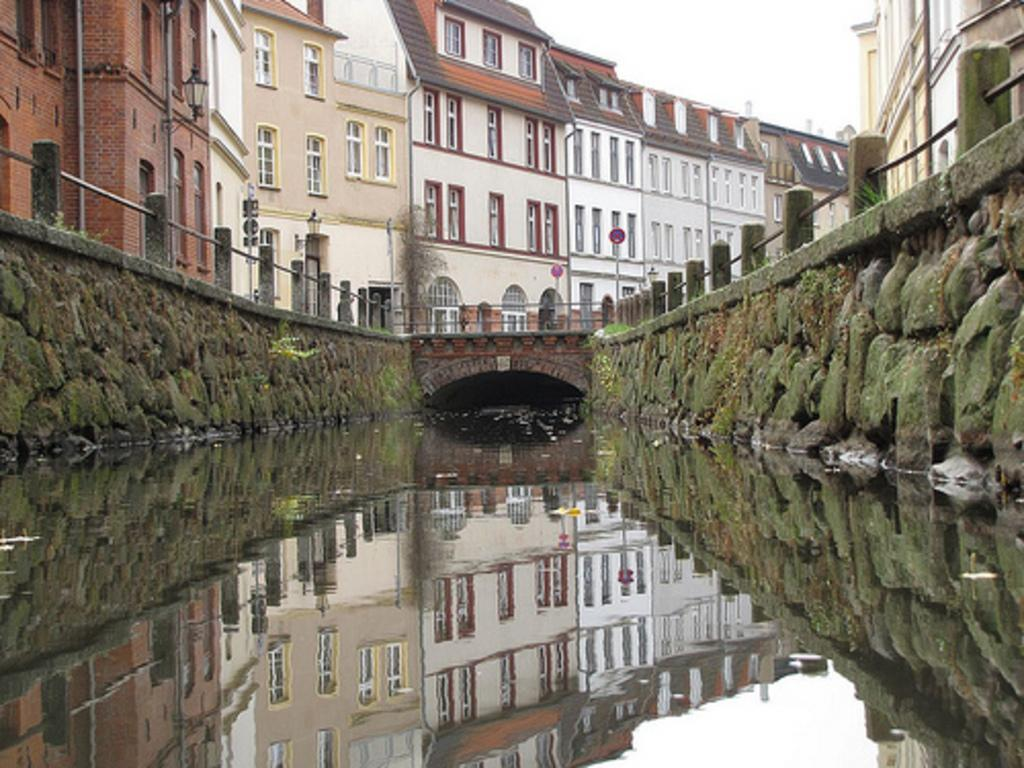What type of structure is present in the image? There is a bridge in the image. What can be seen flowing beneath the bridge? There is water visible in the image. What surrounds the bridge on both sides? There are rock walls on both sides of the bridge. What else can be seen in the image besides the bridge and water? There are buildings and a tree near the bridge. What is visible above the bridge and buildings? The sky is visible in the image. How many cards are being used for science experiments in the image? There are no cards or science experiments present in the image. Can you see any sheep grazing near the bridge in the image? There are no sheep visible in the image. 